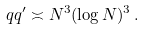<formula> <loc_0><loc_0><loc_500><loc_500>q q ^ { \prime } \asymp N ^ { 3 } ( \log N ) ^ { 3 } \, .</formula> 